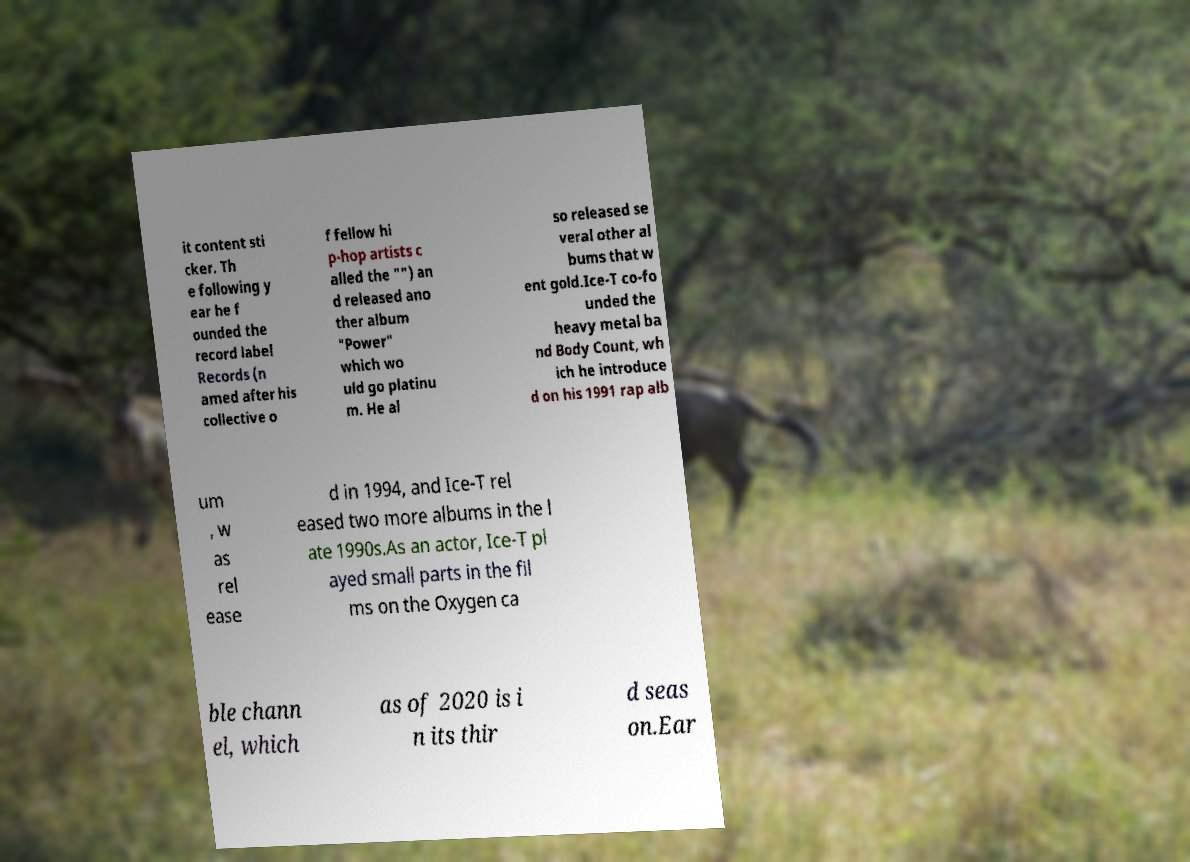Could you assist in decoding the text presented in this image and type it out clearly? it content sti cker. Th e following y ear he f ounded the record label Records (n amed after his collective o f fellow hi p-hop artists c alled the "") an d released ano ther album "Power" which wo uld go platinu m. He al so released se veral other al bums that w ent gold.Ice-T co-fo unded the heavy metal ba nd Body Count, wh ich he introduce d on his 1991 rap alb um , w as rel ease d in 1994, and Ice-T rel eased two more albums in the l ate 1990s.As an actor, Ice-T pl ayed small parts in the fil ms on the Oxygen ca ble chann el, which as of 2020 is i n its thir d seas on.Ear 